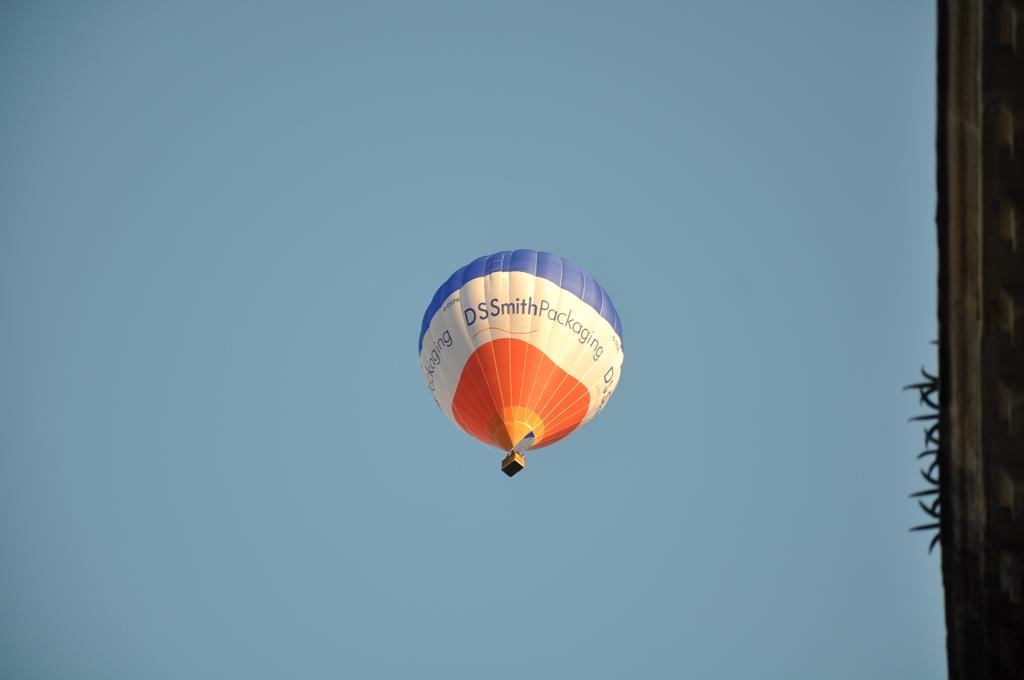<image>
Share a concise interpretation of the image provided. A blue, white and orange hot air balloon advertising DSSmithPackaging floating up into the blue sky. 